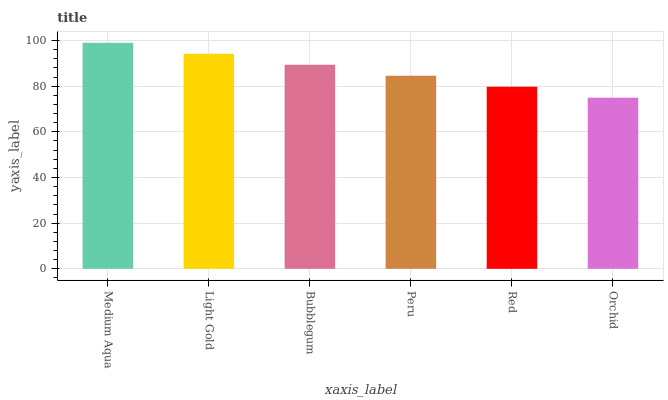Is Orchid the minimum?
Answer yes or no. Yes. Is Medium Aqua the maximum?
Answer yes or no. Yes. Is Light Gold the minimum?
Answer yes or no. No. Is Light Gold the maximum?
Answer yes or no. No. Is Medium Aqua greater than Light Gold?
Answer yes or no. Yes. Is Light Gold less than Medium Aqua?
Answer yes or no. Yes. Is Light Gold greater than Medium Aqua?
Answer yes or no. No. Is Medium Aqua less than Light Gold?
Answer yes or no. No. Is Bubblegum the high median?
Answer yes or no. Yes. Is Peru the low median?
Answer yes or no. Yes. Is Medium Aqua the high median?
Answer yes or no. No. Is Light Gold the low median?
Answer yes or no. No. 